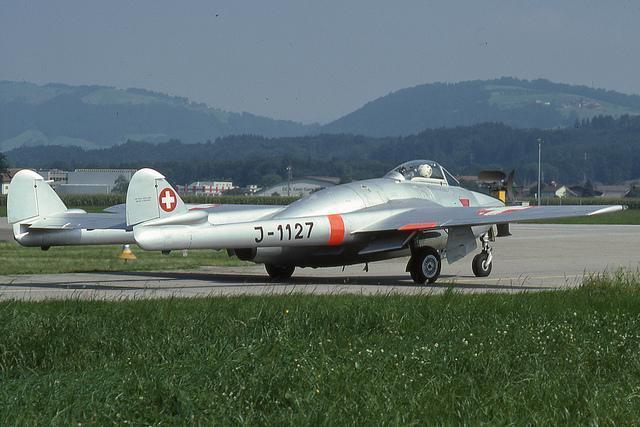How many airplanes can you see?
Give a very brief answer. 2. 